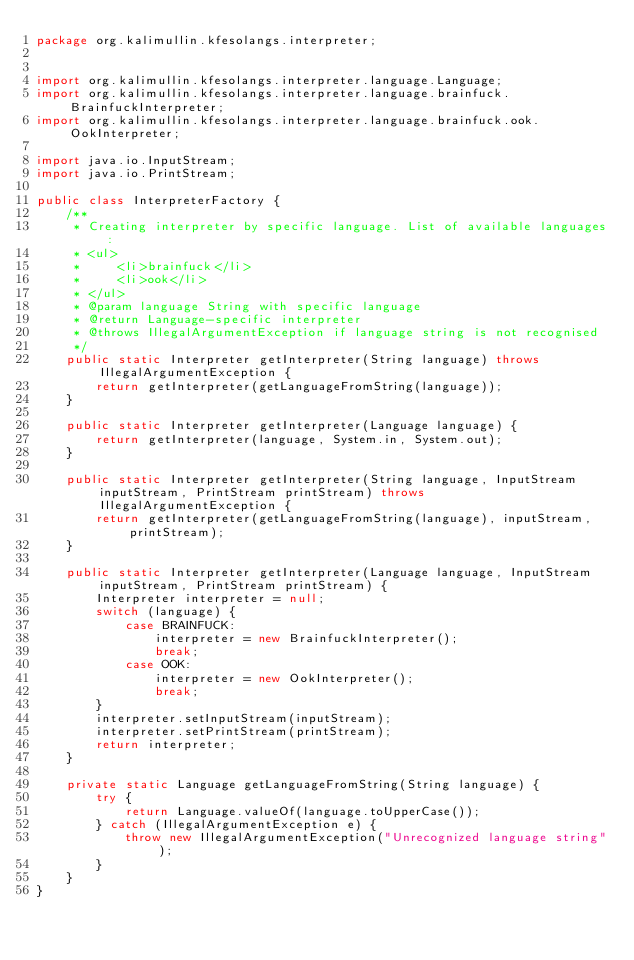<code> <loc_0><loc_0><loc_500><loc_500><_Java_>package org.kalimullin.kfesolangs.interpreter;


import org.kalimullin.kfesolangs.interpreter.language.Language;
import org.kalimullin.kfesolangs.interpreter.language.brainfuck.BrainfuckInterpreter;
import org.kalimullin.kfesolangs.interpreter.language.brainfuck.ook.OokInterpreter;

import java.io.InputStream;
import java.io.PrintStream;

public class InterpreterFactory {
    /**
     * Creating interpreter by specific language. List of available languages:
     * <ul>
     *     <li>brainfuck</li>
     *     <li>ook</li>
     * </ul>
     * @param language String with specific language
     * @return Language-specific interpreter
     * @throws IllegalArgumentException if language string is not recognised
     */
    public static Interpreter getInterpreter(String language) throws IllegalArgumentException {
        return getInterpreter(getLanguageFromString(language));
    }

    public static Interpreter getInterpreter(Language language) {
        return getInterpreter(language, System.in, System.out);
    }

    public static Interpreter getInterpreter(String language, InputStream inputStream, PrintStream printStream) throws IllegalArgumentException {
        return getInterpreter(getLanguageFromString(language), inputStream, printStream);
    }

    public static Interpreter getInterpreter(Language language, InputStream inputStream, PrintStream printStream) {
        Interpreter interpreter = null;
        switch (language) {
            case BRAINFUCK:
                interpreter = new BrainfuckInterpreter();
                break;
            case OOK:
                interpreter = new OokInterpreter();
                break;
        }
        interpreter.setInputStream(inputStream);
        interpreter.setPrintStream(printStream);
        return interpreter;
    }

    private static Language getLanguageFromString(String language) {
        try {
            return Language.valueOf(language.toUpperCase());
        } catch (IllegalArgumentException e) {
            throw new IllegalArgumentException("Unrecognized language string");
        }
    }
}
</code> 